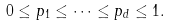Convert formula to latex. <formula><loc_0><loc_0><loc_500><loc_500>0 \leq p _ { 1 } \leq \dots \leq p _ { d } \leq 1 .</formula> 